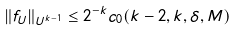Convert formula to latex. <formula><loc_0><loc_0><loc_500><loc_500>\| f _ { U } \| _ { U ^ { k - 1 } } \leq 2 ^ { - k } c _ { 0 } ( k - 2 , k , \delta , M )</formula> 